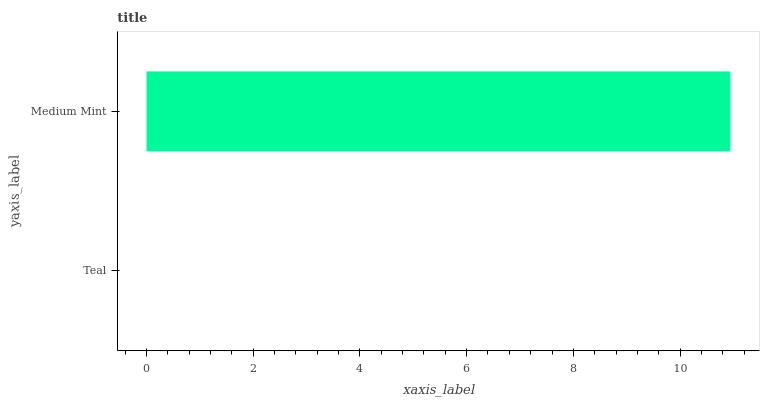Is Teal the minimum?
Answer yes or no. Yes. Is Medium Mint the maximum?
Answer yes or no. Yes. Is Medium Mint the minimum?
Answer yes or no. No. Is Medium Mint greater than Teal?
Answer yes or no. Yes. Is Teal less than Medium Mint?
Answer yes or no. Yes. Is Teal greater than Medium Mint?
Answer yes or no. No. Is Medium Mint less than Teal?
Answer yes or no. No. Is Medium Mint the high median?
Answer yes or no. Yes. Is Teal the low median?
Answer yes or no. Yes. Is Teal the high median?
Answer yes or no. No. Is Medium Mint the low median?
Answer yes or no. No. 